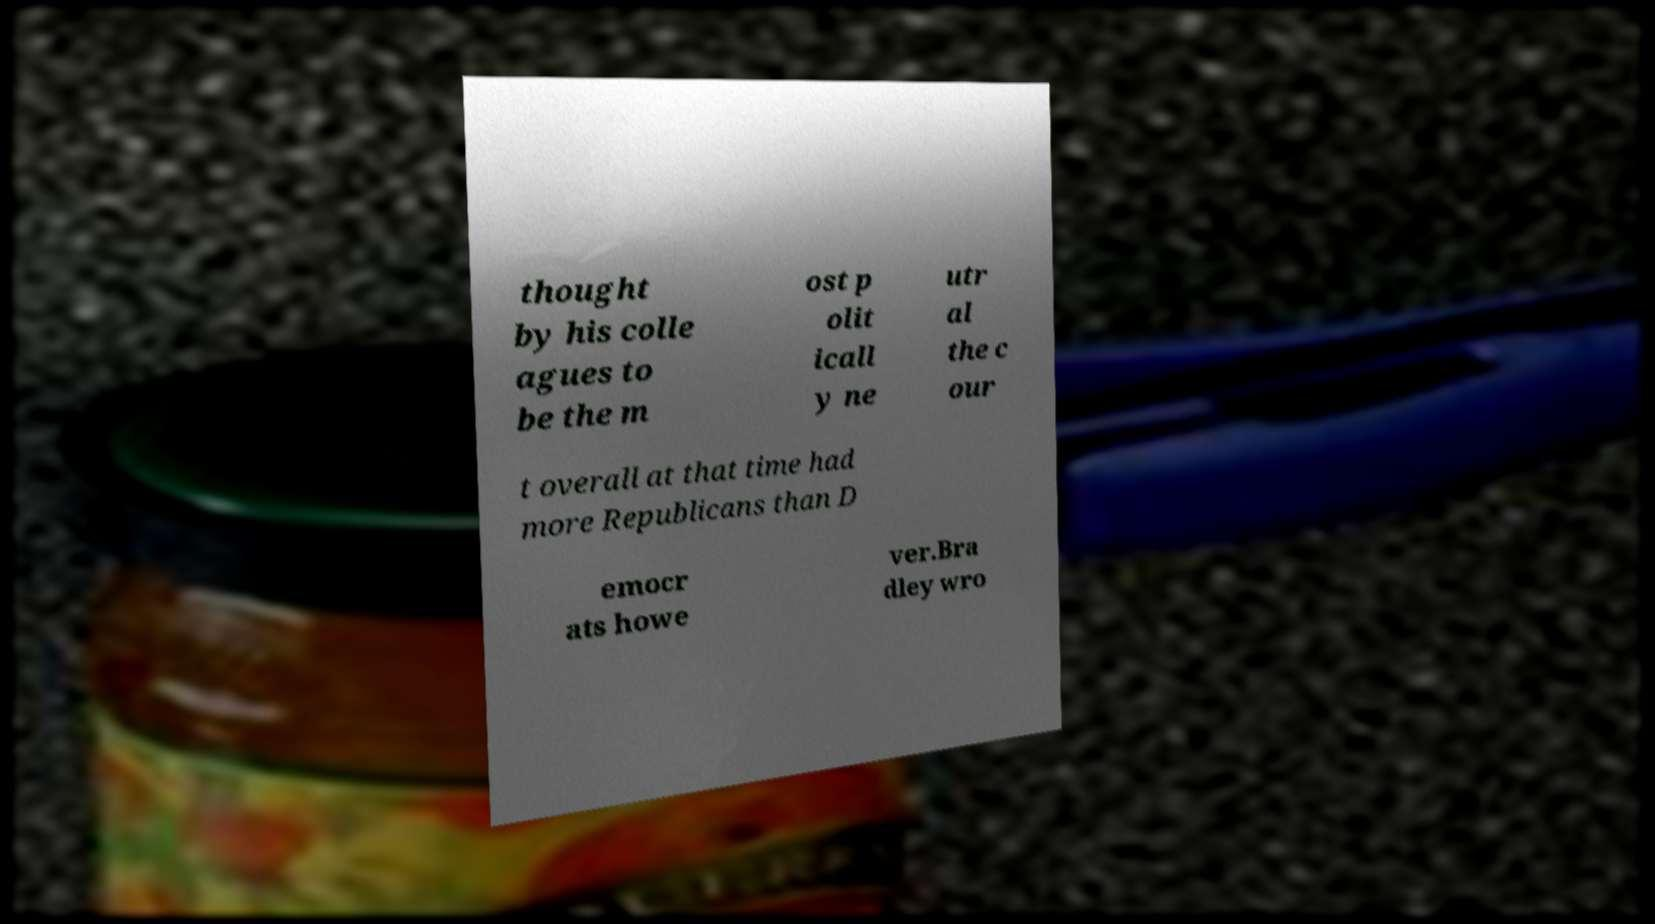Can you read and provide the text displayed in the image?This photo seems to have some interesting text. Can you extract and type it out for me? thought by his colle agues to be the m ost p olit icall y ne utr al the c our t overall at that time had more Republicans than D emocr ats howe ver.Bra dley wro 